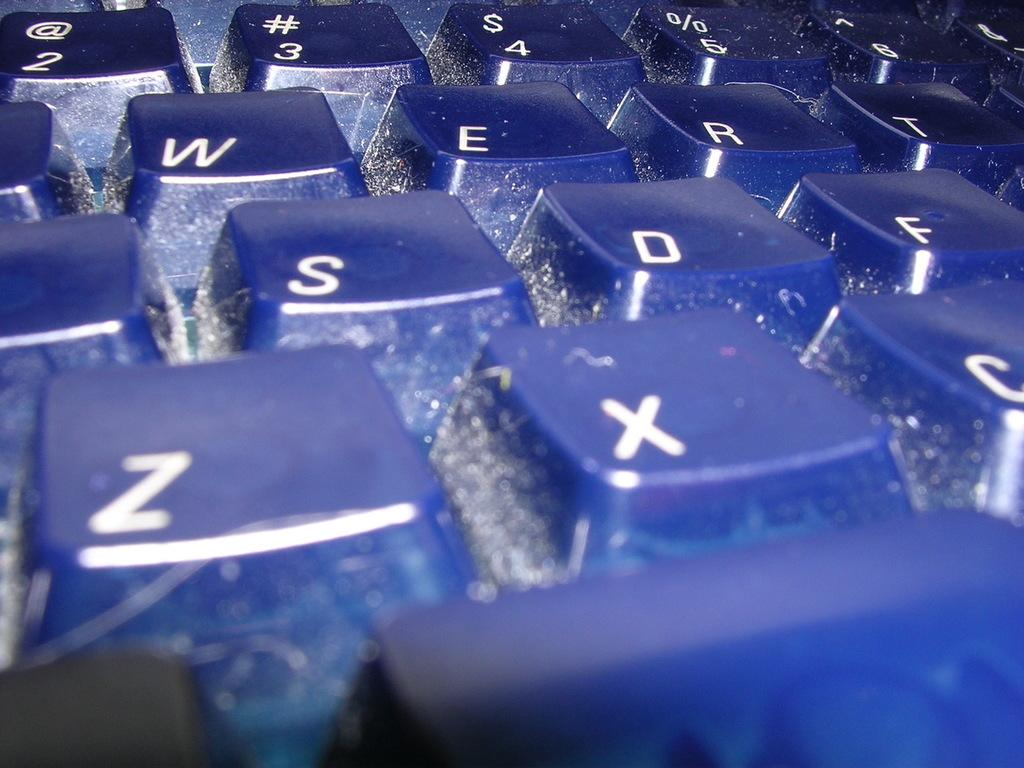What is the main object in the image? There is a keyboard in the image. What part of the keyboard is visible? The keys of the keyboard are visible. What can be seen on the keys of the keyboard? There is writing on the keys of the keyboard. What type of rain can be seen falling on the keyboard in the image? There is no rain present in the image; it is a keyboard with visible keys and writing on them. 